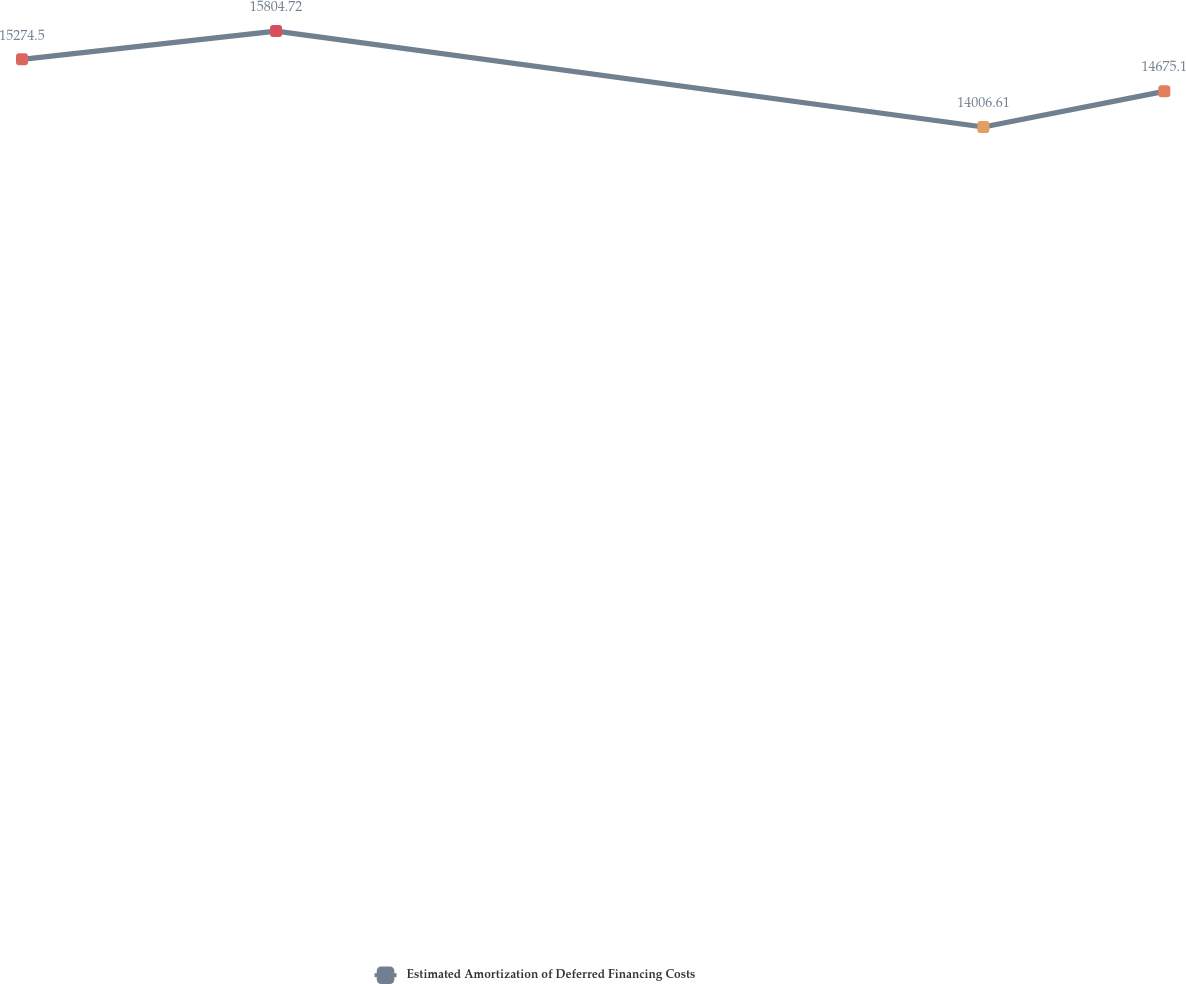<chart> <loc_0><loc_0><loc_500><loc_500><line_chart><ecel><fcel>Estimated Amortization of Deferred Financing Costs<nl><fcel>1686.48<fcel>15274.5<nl><fcel>1805.36<fcel>15804.7<nl><fcel>2136.35<fcel>14006.6<nl><fcel>2220.99<fcel>14675.1<nl><fcel>2285.43<fcel>10347.3<nl></chart> 